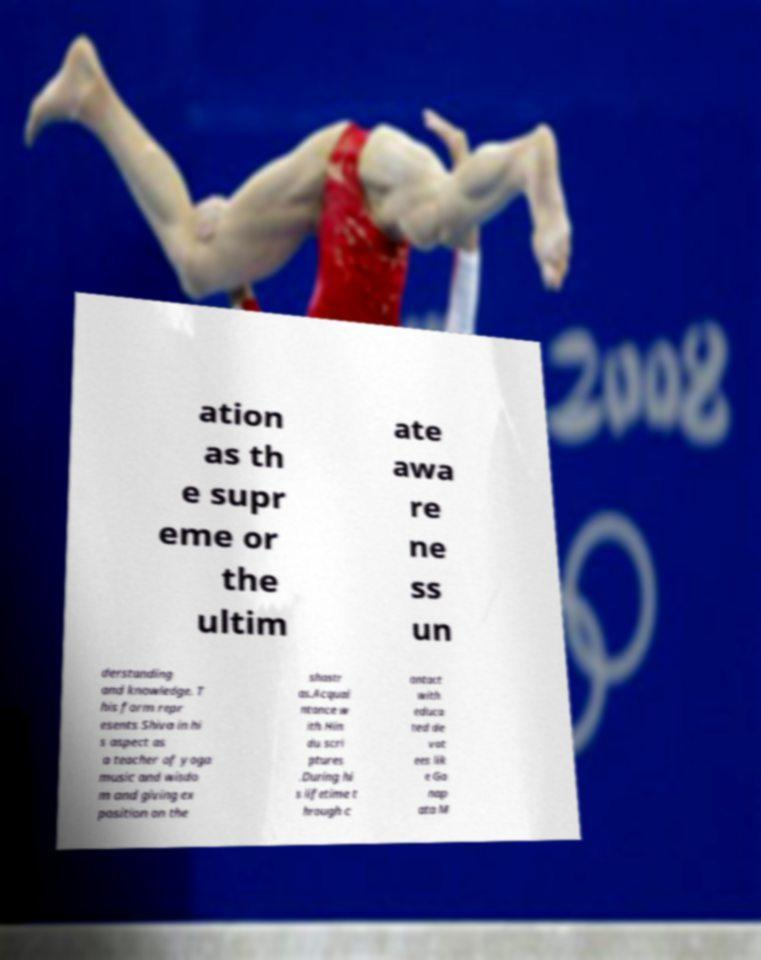What messages or text are displayed in this image? I need them in a readable, typed format. ation as th e supr eme or the ultim ate awa re ne ss un derstanding and knowledge. T his form repr esents Shiva in hi s aspect as a teacher of yoga music and wisdo m and giving ex position on the shastr as.Acquai ntance w ith Hin du scri ptures .During hi s lifetime t hrough c ontact with educa ted de vot ees lik e Ga nap ata M 